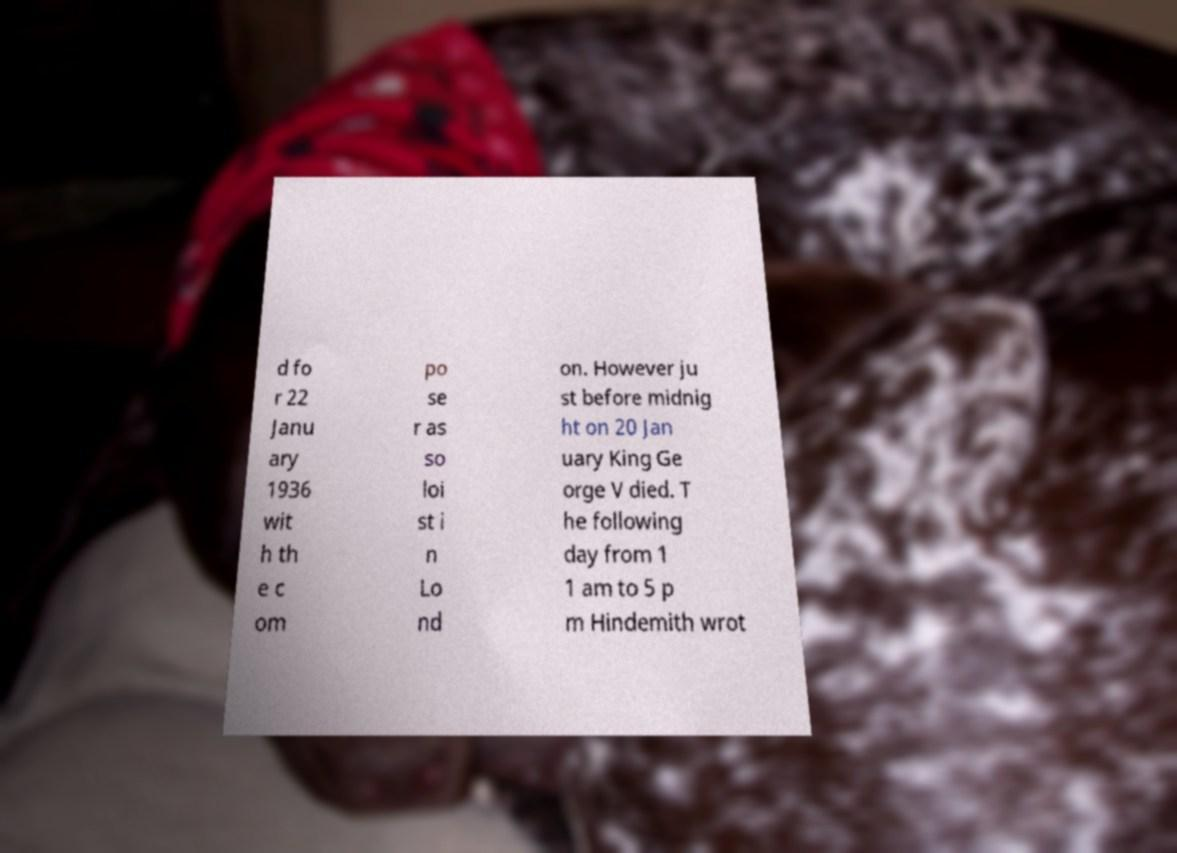Please identify and transcribe the text found in this image. d fo r 22 Janu ary 1936 wit h th e c om po se r as so loi st i n Lo nd on. However ju st before midnig ht on 20 Jan uary King Ge orge V died. T he following day from 1 1 am to 5 p m Hindemith wrot 